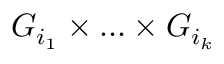<formula> <loc_0><loc_0><loc_500><loc_500>G _ { i _ { 1 } } \times \dots \times G _ { i _ { k } }</formula> 